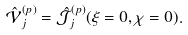Convert formula to latex. <formula><loc_0><loc_0><loc_500><loc_500>\hat { \mathcal { V } } _ { j } ^ { ( p ) } = \hat { \mathcal { J } } _ { j } ^ { ( p ) } ( \xi = 0 , \chi = 0 ) .</formula> 